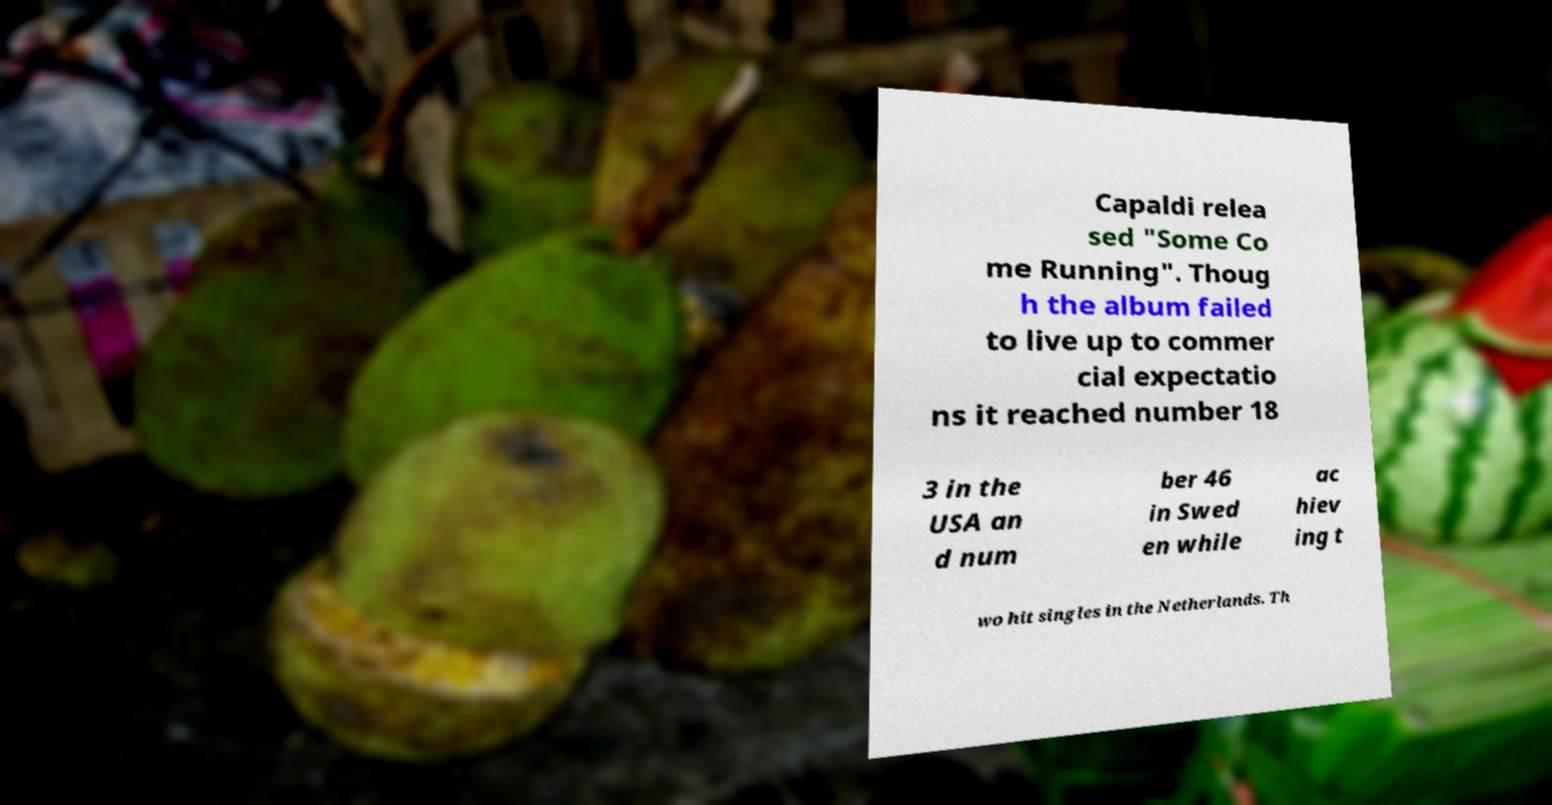Can you read and provide the text displayed in the image?This photo seems to have some interesting text. Can you extract and type it out for me? Capaldi relea sed "Some Co me Running". Thoug h the album failed to live up to commer cial expectatio ns it reached number 18 3 in the USA an d num ber 46 in Swed en while ac hiev ing t wo hit singles in the Netherlands. Th 